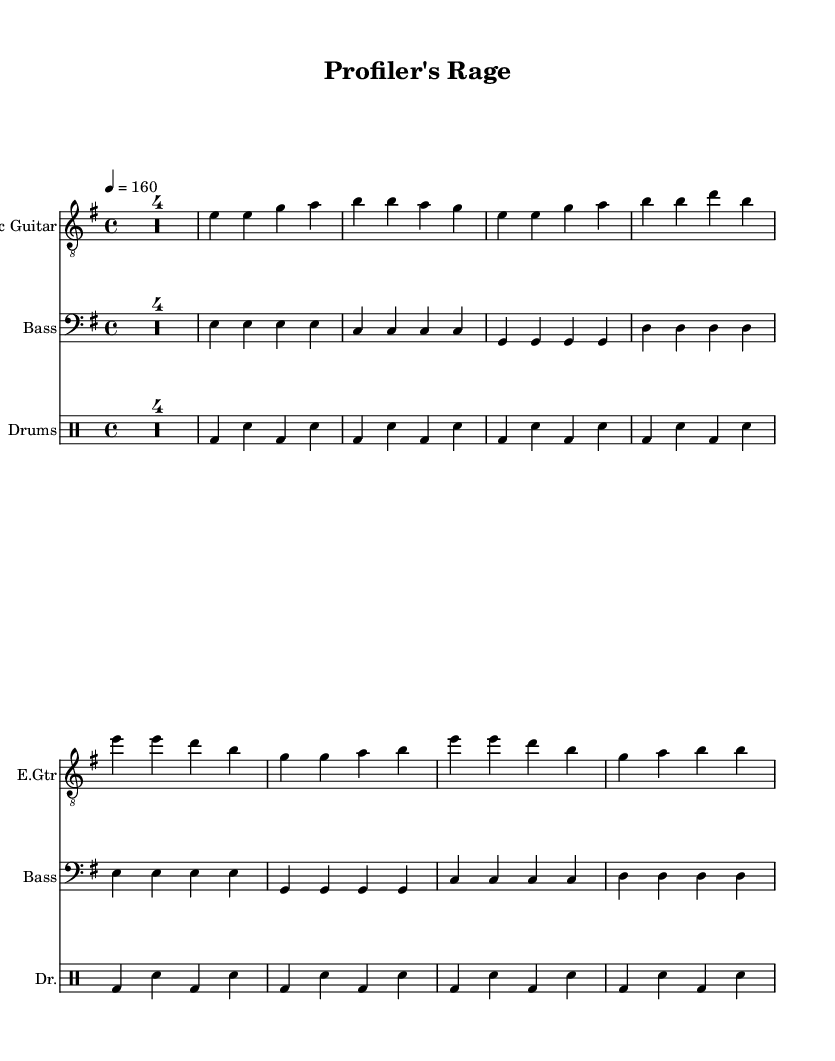What is the key signature of this music? The key signature is indicated by the number of sharps or flats at the beginning of the staff. In this case, it is specified as E minor, which has one sharp (F#).
Answer: E minor What is the time signature of this piece? The time signature is found at the start of the music. Here, it is indicated as 4/4, which means there are four beats in a measure and the quarter note receives one beat.
Answer: 4/4 What is the tempo marking of this music? The tempo marking is stated in the score near the top, denoting the speed of the piece. In this case, it is marked as 160 beats per minute.
Answer: 160 How many measures are in the electric guitar part? By counting the distinct groups of notes separated by the bar lines in the electric guitar part, we can determine the number of measures. There are 8 measures listed in the part.
Answer: 8 What instrument plays the main riff? The main riff or melody is typically found in the treble line, which corresponds to the electric guitar part in this score.
Answer: Electric Guitar Which section contains the lyrics "We're the B-A-U, we'll crack the case"? The lyrics are embedded into the structure of the song. The phrase provided is part of the chorus, which follows the verse section in punk music typically.
Answer: Chorus What musical style is indicated by the title of this piece? The title "Profiler's Rage" suggests a thematic focus on crime-solving, resonating with the punk genre's typical themes of rebellion and social issues, linking it closely with crime narratives.
Answer: Punk 